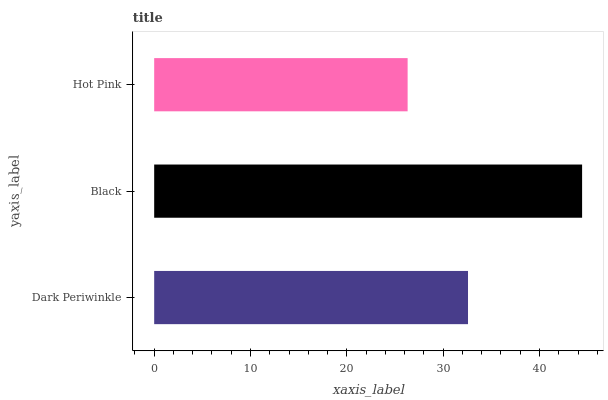Is Hot Pink the minimum?
Answer yes or no. Yes. Is Black the maximum?
Answer yes or no. Yes. Is Black the minimum?
Answer yes or no. No. Is Hot Pink the maximum?
Answer yes or no. No. Is Black greater than Hot Pink?
Answer yes or no. Yes. Is Hot Pink less than Black?
Answer yes or no. Yes. Is Hot Pink greater than Black?
Answer yes or no. No. Is Black less than Hot Pink?
Answer yes or no. No. Is Dark Periwinkle the high median?
Answer yes or no. Yes. Is Dark Periwinkle the low median?
Answer yes or no. Yes. Is Hot Pink the high median?
Answer yes or no. No. Is Hot Pink the low median?
Answer yes or no. No. 